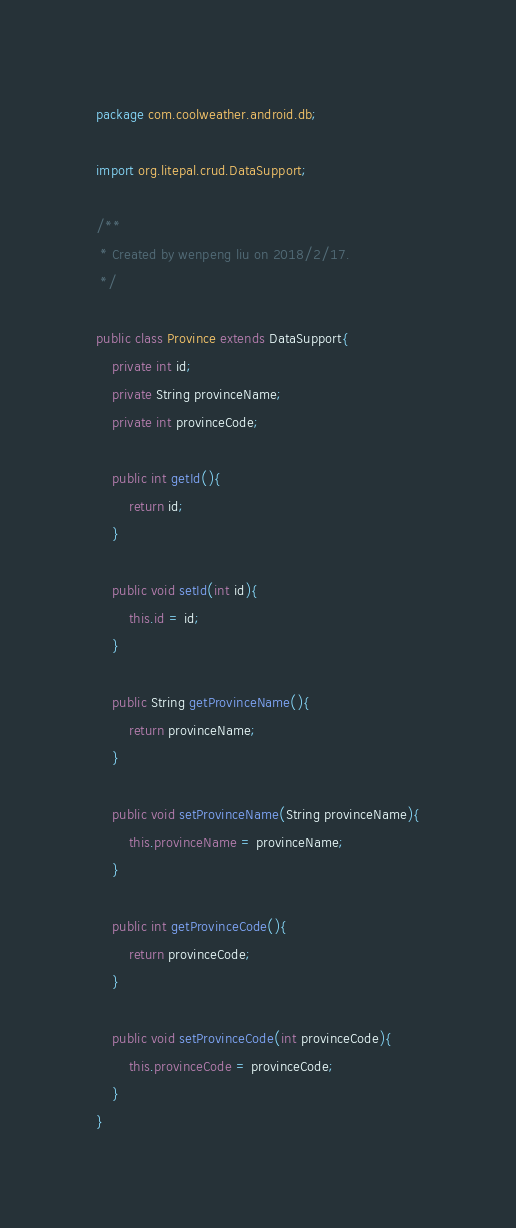<code> <loc_0><loc_0><loc_500><loc_500><_Java_>package com.coolweather.android.db;

import org.litepal.crud.DataSupport;

/**
 * Created by wenpeng liu on 2018/2/17.
 */

public class Province extends DataSupport{
    private int id;
    private String provinceName;
    private int provinceCode;

    public int getId(){
        return id;
    }

    public void setId(int id){
        this.id = id;
    }

    public String getProvinceName(){
        return provinceName;
    }

    public void setProvinceName(String provinceName){
        this.provinceName = provinceName;
    }

    public int getProvinceCode(){
        return provinceCode;
    }

    public void setProvinceCode(int provinceCode){
        this.provinceCode = provinceCode;
    }
}
</code> 